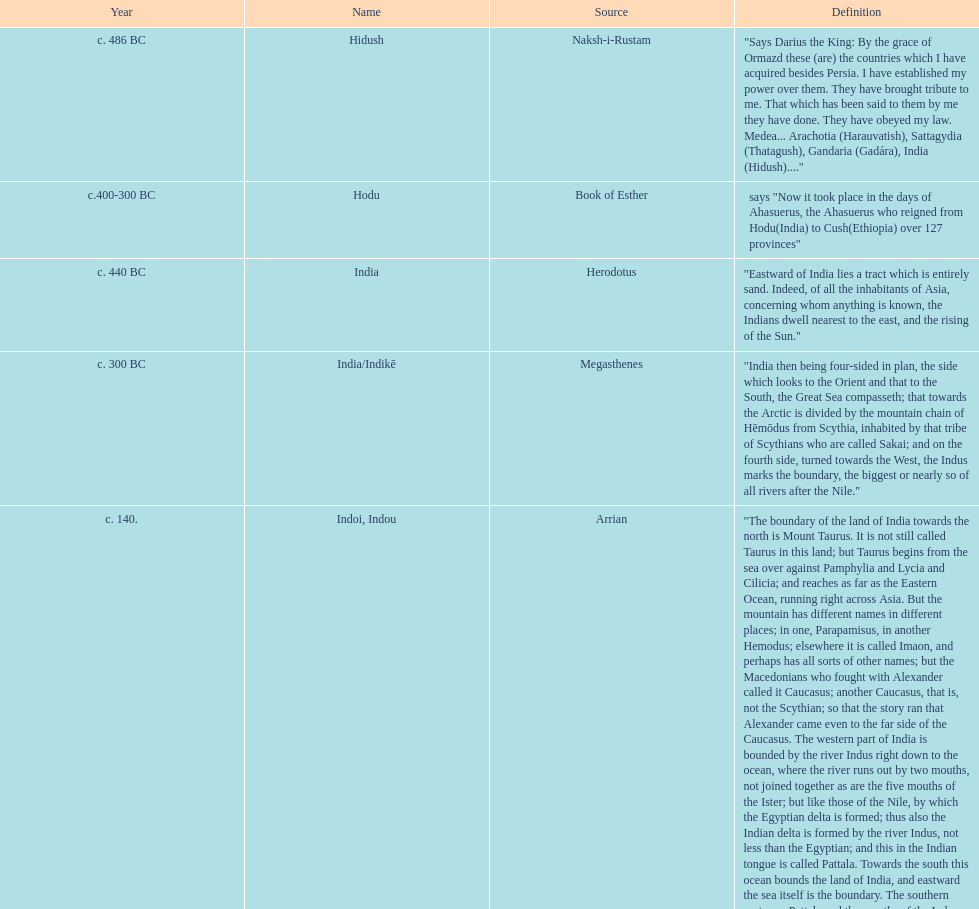Before the book of esther used the name hodu, what was the nation known as? Hidush. 